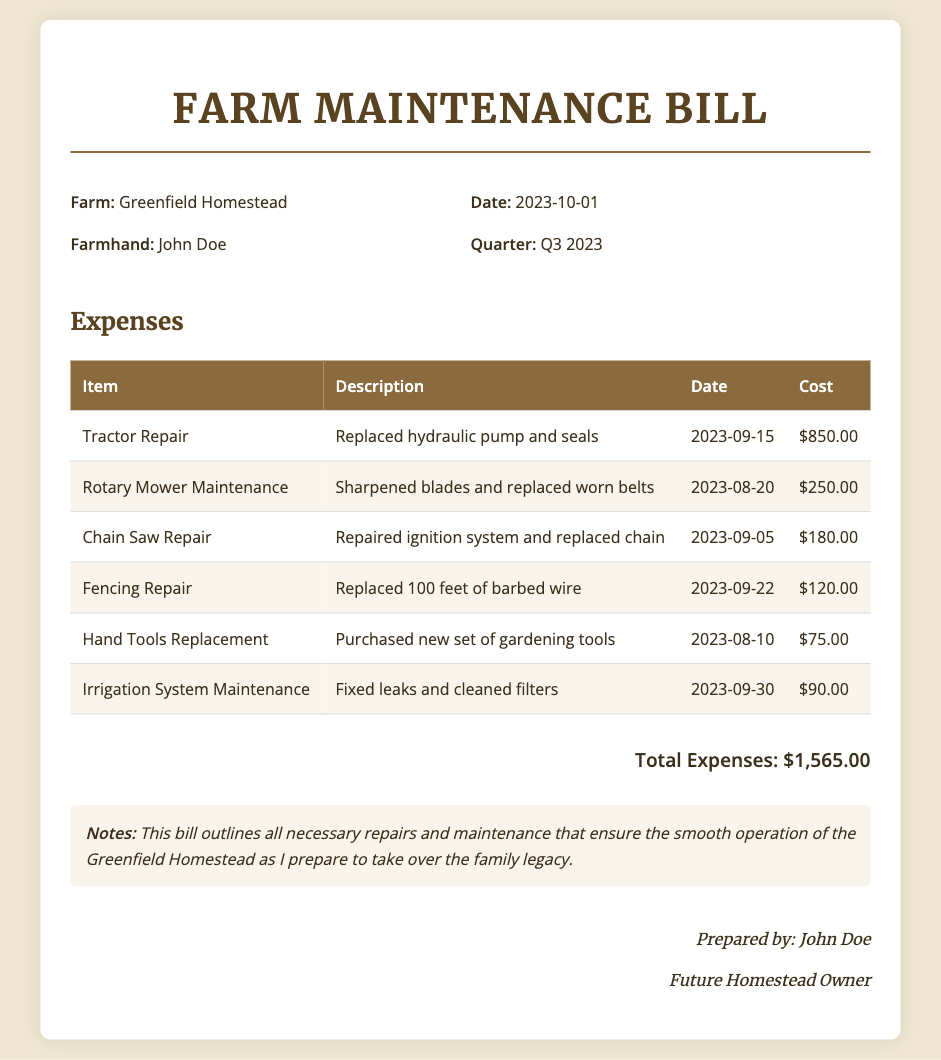what is the total cost of the expenses? The total cost of the expenses is listed at the bottom of the table in the document.
Answer: $1,565.00 who prepared the document? The document states who prepared it at the end, along with their title.
Answer: John Doe what type of repair was done on September 15, 2023? The date corresponds to a specific repair listed in the expenses table.
Answer: Tractor Repair how many feet of barbed wire were replaced in the fencing repair? The description in the fencing repair entry specifies the length of barbed wire replaced.
Answer: 100 feet which item had the least cost in the expenses? The expenses table shows individual costs, which can be compared to find the lowest.
Answer: Hand Tools Replacement what is the date of the bill? The document specifies this important date in the bill info section.
Answer: 2023-10-01 which type of maintenance was performed most recently? The most recent repair date can be identified from the table and refers to a specific maintenance activity.
Answer: Irrigation System Maintenance what is the description for the Rotary Mower Maintenance? The item description in the expenses table provides details about the service performed.
Answer: Sharpened blades and replaced worn belts 